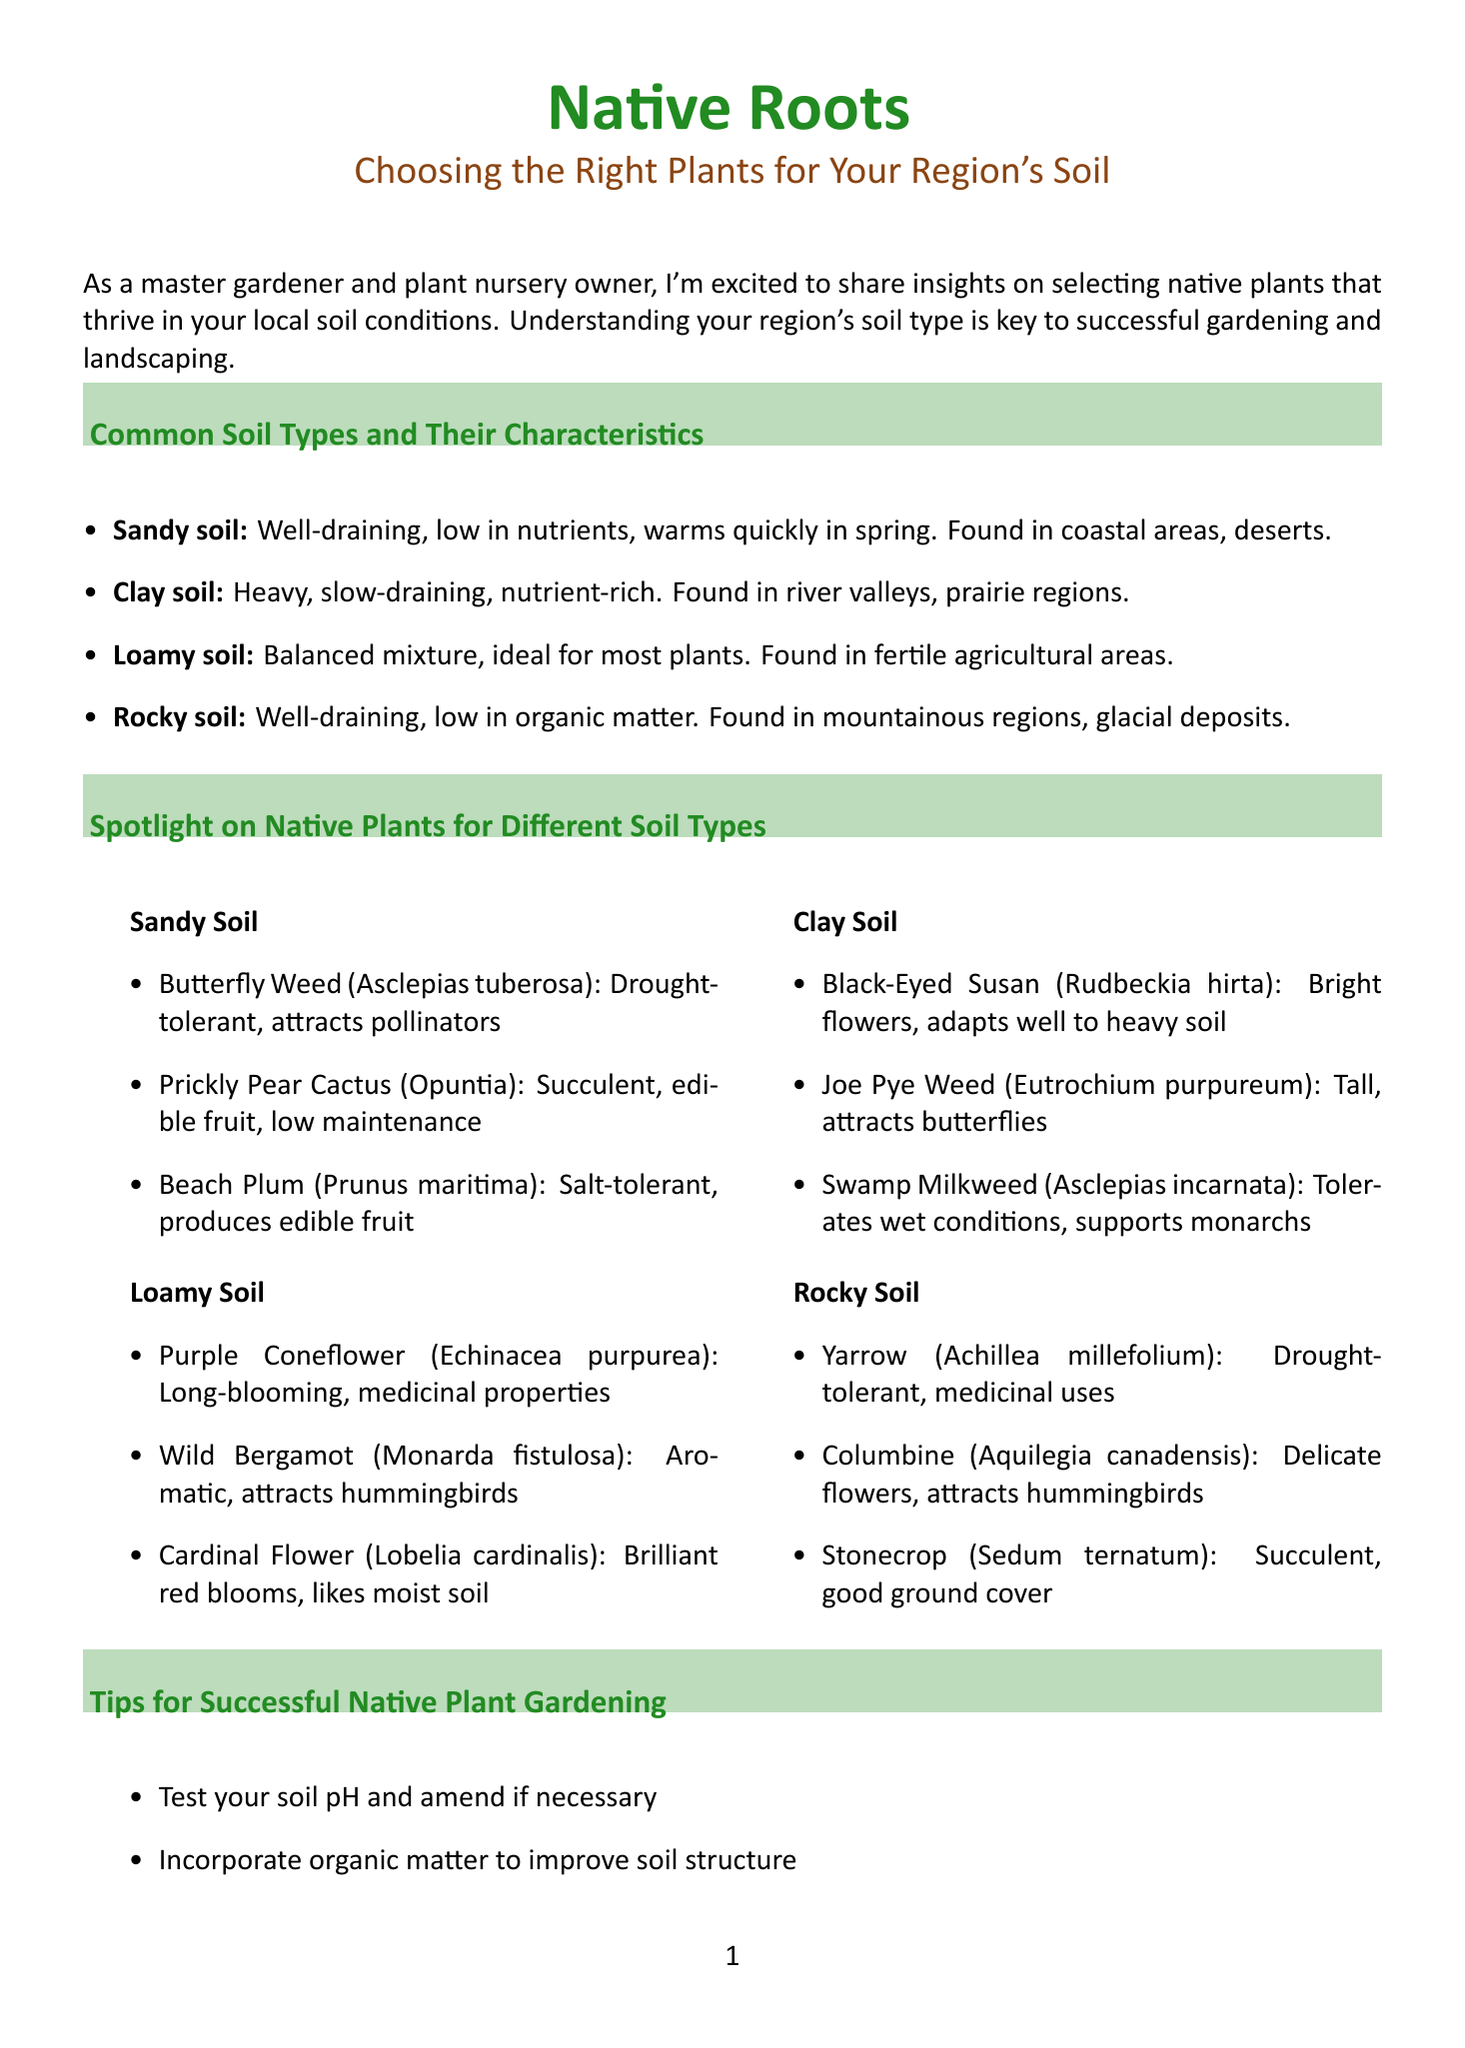What are the four common soil types mentioned? The document lists four soil types: Sandy soil, Clay soil, Loamy soil, and Rocky soil.
Answer: Sandy soil, Clay soil, Loamy soil, Rocky soil Who is the author of the newsletter? The author is introduced at the end of the document, stating her name and credentials.
Answer: Emily Green What plant is suitable for loamy soil? The document specifies several plants for loamy soil, including the Purple Coneflower.
Answer: Purple Coneflower Which plant attracts butterflies and is suitable for clay soil? The reasoning requires linking the plant type to its flower attribute and given soil conditions for clay.
Answer: Joe Pye Weed What is the first tip for successful native plant gardening? The tips section lists several gardening tips, beginning with soil pH testing.
Answer: Test your soil pH and amend if necessary What characteristic describes sandy soil? The document provides characteristics for sandy soil, including drainage qualities.
Answer: Well-draining Where can you find clay soil? The document lists example locations where clay soil can be found.
Answer: River valleys, prairie regions What feature of the Beach Plum makes it suitable for sandy soil? The document describes the Beach Plum's salt tolerance as an important trait for sandy environments.
Answer: Salt-tolerant What type of soil is ideal for most plants? The characteristics section of the document specifies this as loamy soil.
Answer: Loamy soil 